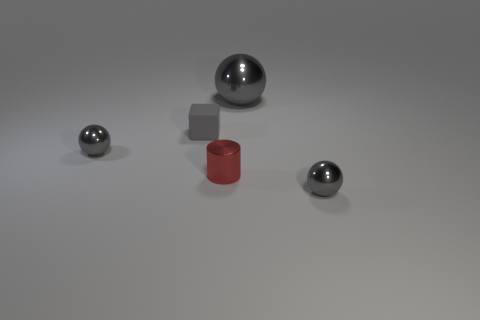What number of yellow objects are either tiny metal things or tiny objects?
Offer a terse response. 0. Is there a tiny object of the same color as the tiny matte block?
Ensure brevity in your answer.  Yes. There is a red object that is the same material as the large gray thing; what is its size?
Make the answer very short. Small. What number of balls are either matte things or tiny gray things?
Your answer should be compact. 2. Are there more tiny things than balls?
Offer a very short reply. Yes. How many red metallic objects are the same size as the cylinder?
Give a very brief answer. 0. What shape is the small matte object that is the same color as the large metallic ball?
Your response must be concise. Cube. How many objects are gray spheres that are in front of the large ball or big cyan shiny cubes?
Keep it short and to the point. 2. Are there fewer matte things than green metallic cubes?
Your answer should be very brief. No. There is a big thing that is made of the same material as the red cylinder; what is its shape?
Give a very brief answer. Sphere. 